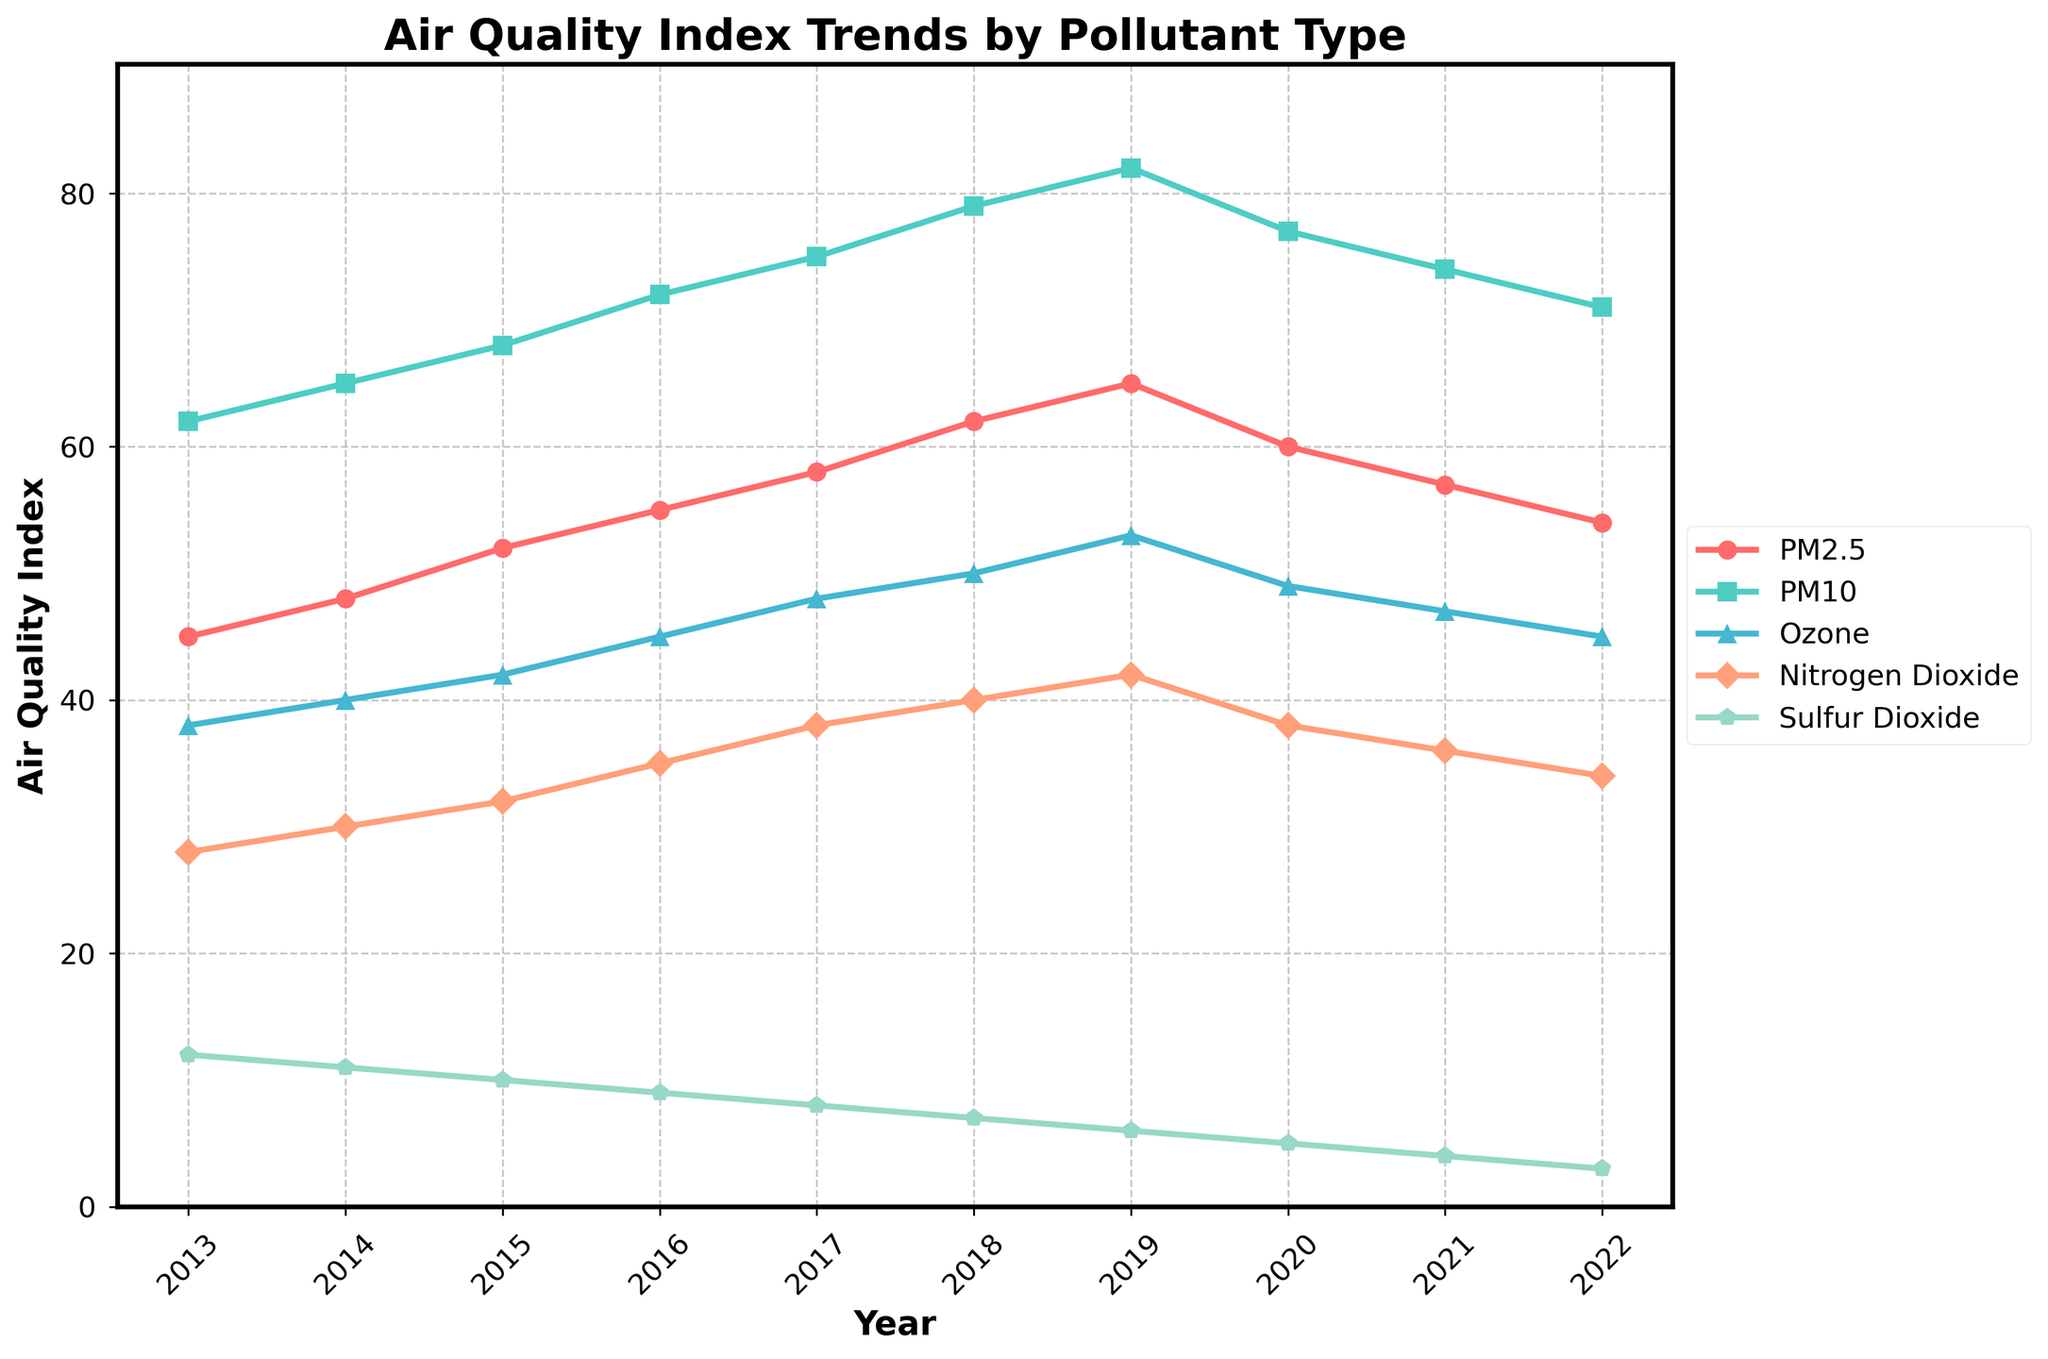What's the general trend of PM2.5 levels from 2013 to 2022? The PM2.5 levels generally increase from 45 in 2013 to a peak of 65 in 2019, followed by a decline to 54 by 2022. This indicates an initial worsening in air quality due to PM2.5, followed by a slight improvement.
Answer: Increase, then decrease In which year was the Ozone level the highest? To determine the highest Ozone level, observe the plot for the line corresponding to Ozone. The Ozone level peaks at 53 in 2019.
Answer: 2019 How does the trend of Sulfur Dioxide differ from Nitrogen Dioxide over the decade? Sulfur Dioxide decreases steadily from 12 in 2013 to 3 in 2022. In contrast, Nitrogen Dioxide increases from 28 in 2013 to 42 in 2019, and then decreases to 34 by 2022.
Answer: Sulfur Dioxide steadily decreases, Nitrogen Dioxide increases then decreases Which pollutant type had the smallest change from 2013 to 2022? Compare the changes for each pollutant between 2013 and 2022. Sulfur Dioxide has the biggest decrease (12 to 3), and PM2.5 has the smallest relative change (45 to 54).
Answer: PM2.5 What is the average PM10 level for the years 2013 to 2022? Sum the PM10 levels for the years 2013 to 2022 (62 + 65 + 68 + 72 + 75 + 79 + 82 + 77 + 74 + 71 = 725), then divide by the number of years (10).
Answer: 72.5 Between 2019 and 2020, which pollutant showed the largest decrease? Observe the vertical drop for each pollutant between 2019 and 2020. PM2.5 drops by 5 (65 to 60), PM10 by 5 (82 to 77), Ozone by 4 (53 to 49), Nitrogen Dioxide by 4 (42 to 38), and Sulfur Dioxide by 1 (6 to 5).
Answer: PM10 and PM2.5 What is the sum of Nitrogen Dioxide levels for the first five years (2013-2017)? Sum the Nitrogen Dioxide levels for the years 2013 to 2017 (28 + 30 + 32 + 35 + 38).
Answer: 163 By how many units did the Sulfur Dioxide level decrease from 2013 to 2022? Subtract the Sulfur Dioxide level in 2022 from the level in 2013 (12 - 3).
Answer: 9 How does the trend of Ozone compare to PM10? Ozone and PM10 both increase from 2013 to 2019. After 2019, Ozone decreases from 53 to 45 by 2022, and PM10 also decreases from 82 to 71. Overall, their trends are quite similar.
Answer: Similar trends, increase then decrease 